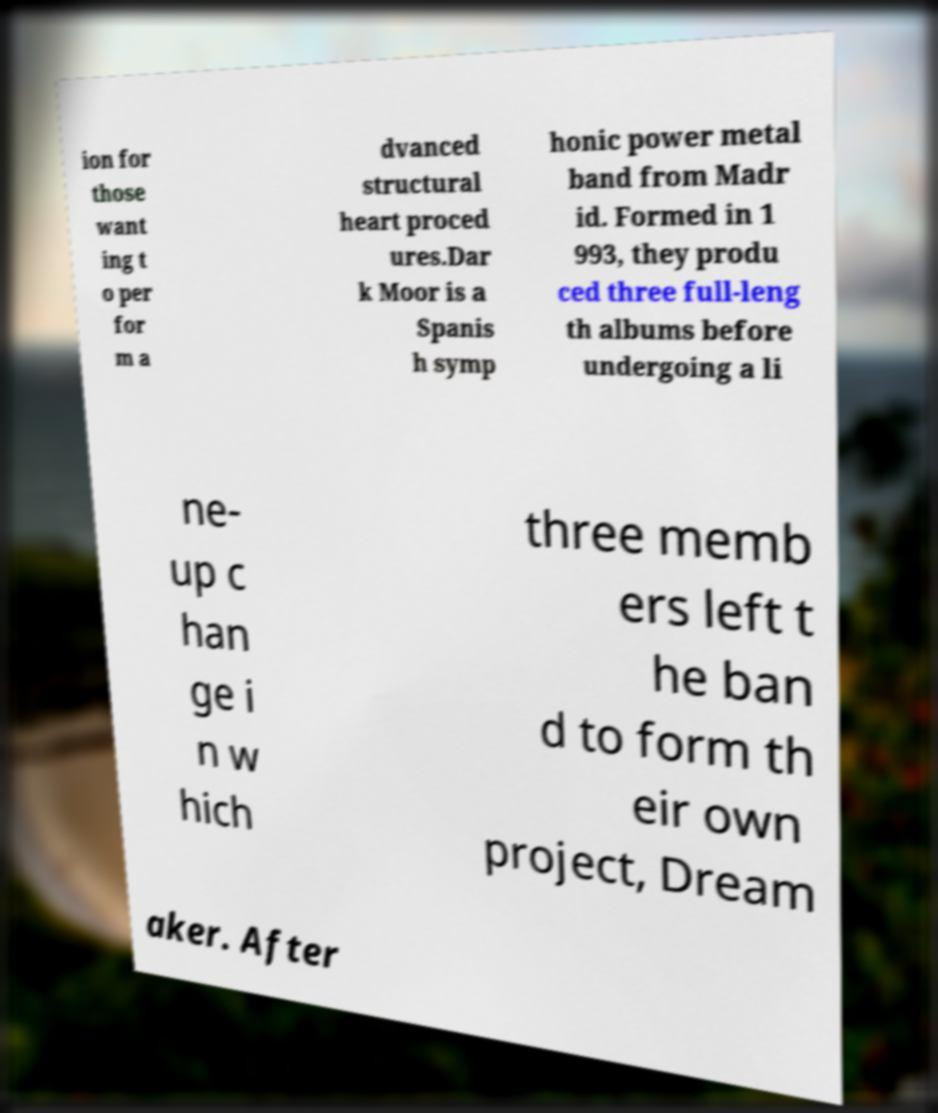What messages or text are displayed in this image? I need them in a readable, typed format. ion for those want ing t o per for m a dvanced structural heart proced ures.Dar k Moor is a Spanis h symp honic power metal band from Madr id. Formed in 1 993, they produ ced three full-leng th albums before undergoing a li ne- up c han ge i n w hich three memb ers left t he ban d to form th eir own project, Dream aker. After 